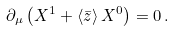<formula> <loc_0><loc_0><loc_500><loc_500>\partial _ { \mu } \left ( X ^ { 1 } + \langle { \bar { z } } \rangle \, X ^ { 0 } \right ) = 0 \, .</formula> 